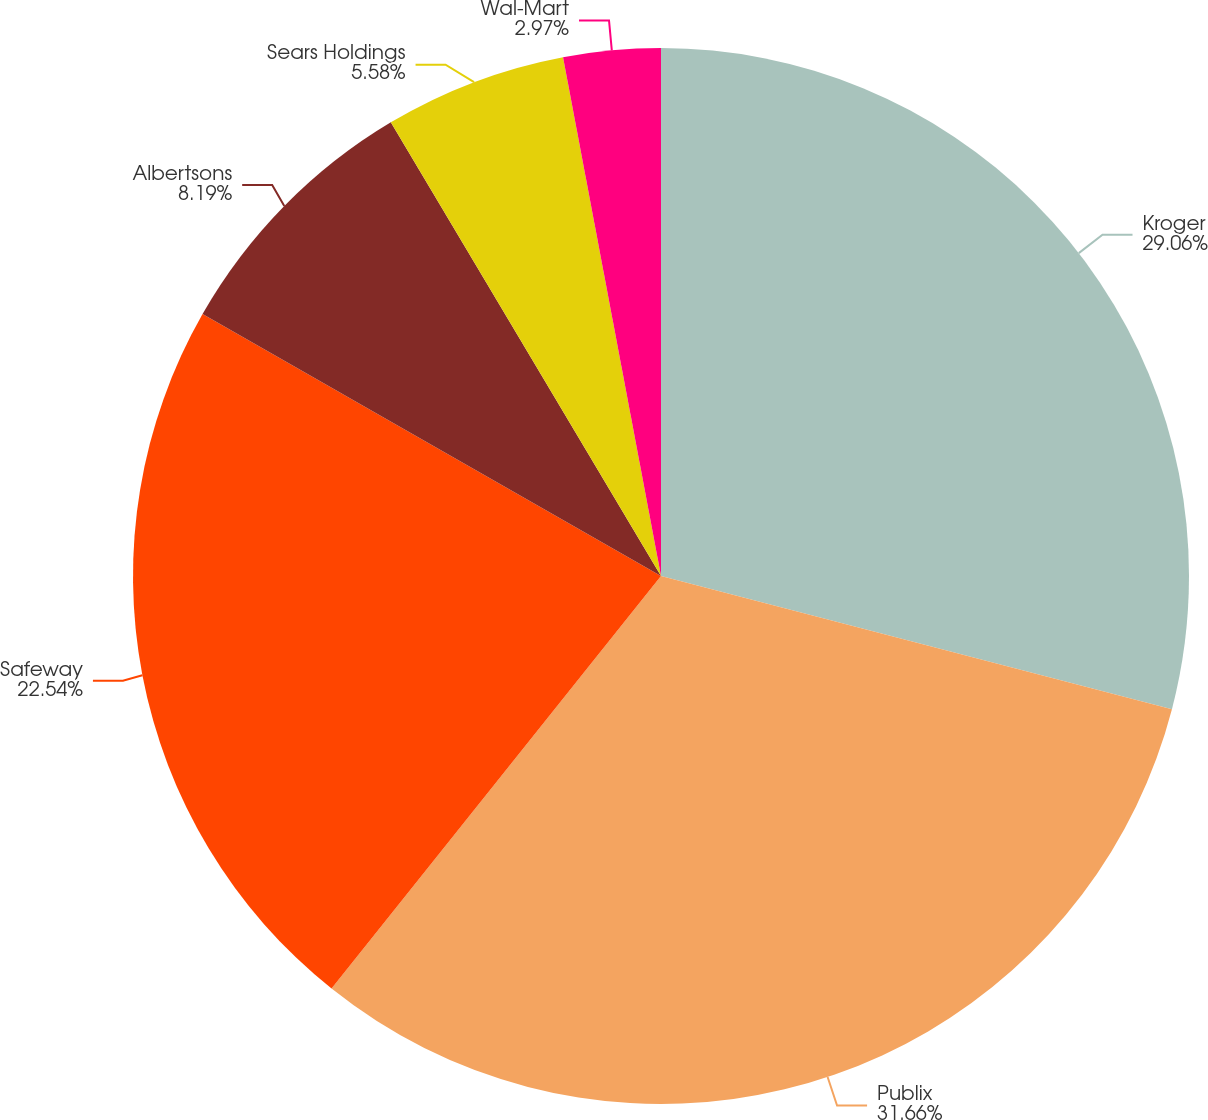<chart> <loc_0><loc_0><loc_500><loc_500><pie_chart><fcel>Kroger<fcel>Publix<fcel>Safeway<fcel>Albertsons<fcel>Sears Holdings<fcel>Wal-Mart<nl><fcel>29.06%<fcel>31.67%<fcel>22.54%<fcel>8.19%<fcel>5.58%<fcel>2.97%<nl></chart> 